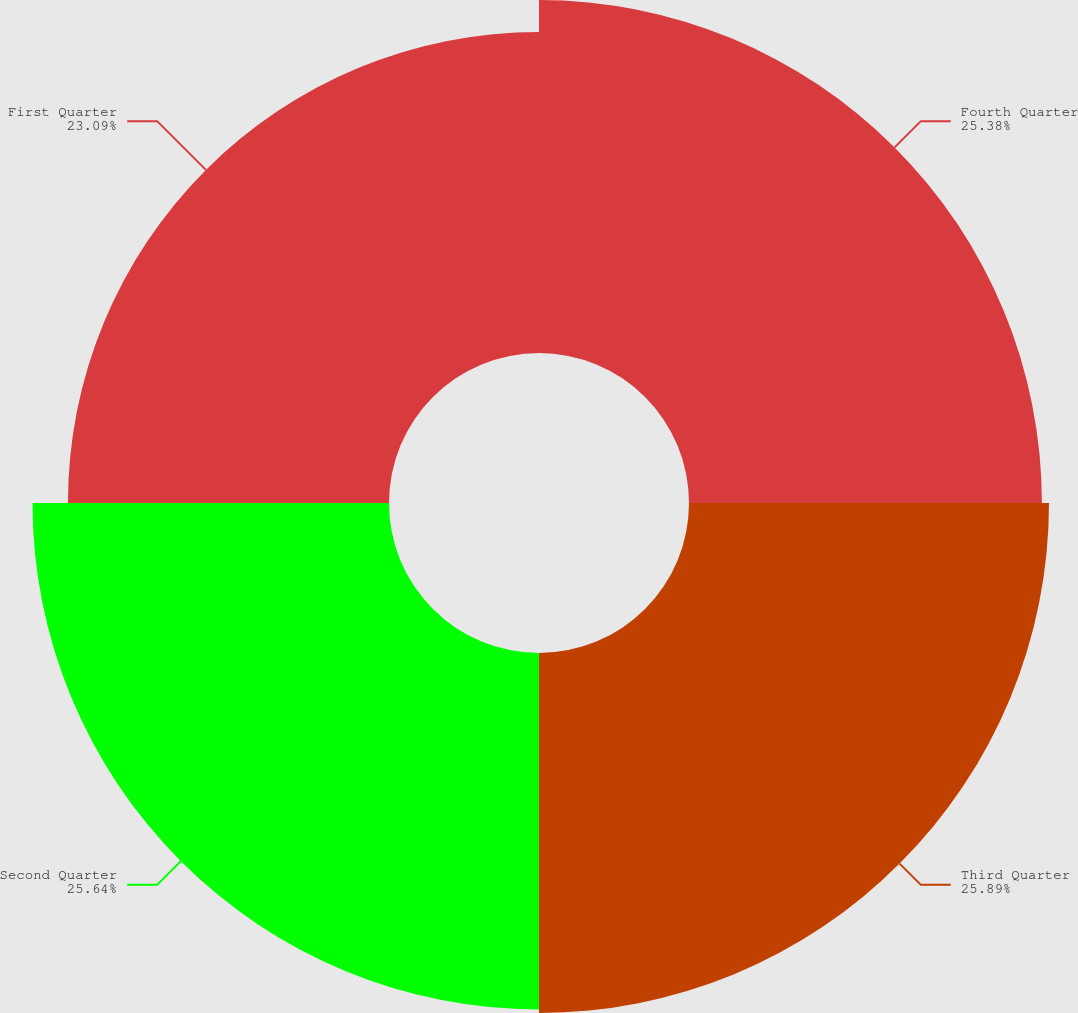Convert chart to OTSL. <chart><loc_0><loc_0><loc_500><loc_500><pie_chart><fcel>Fourth Quarter<fcel>Third Quarter<fcel>Second Quarter<fcel>First Quarter<nl><fcel>25.38%<fcel>25.89%<fcel>25.64%<fcel>23.09%<nl></chart> 